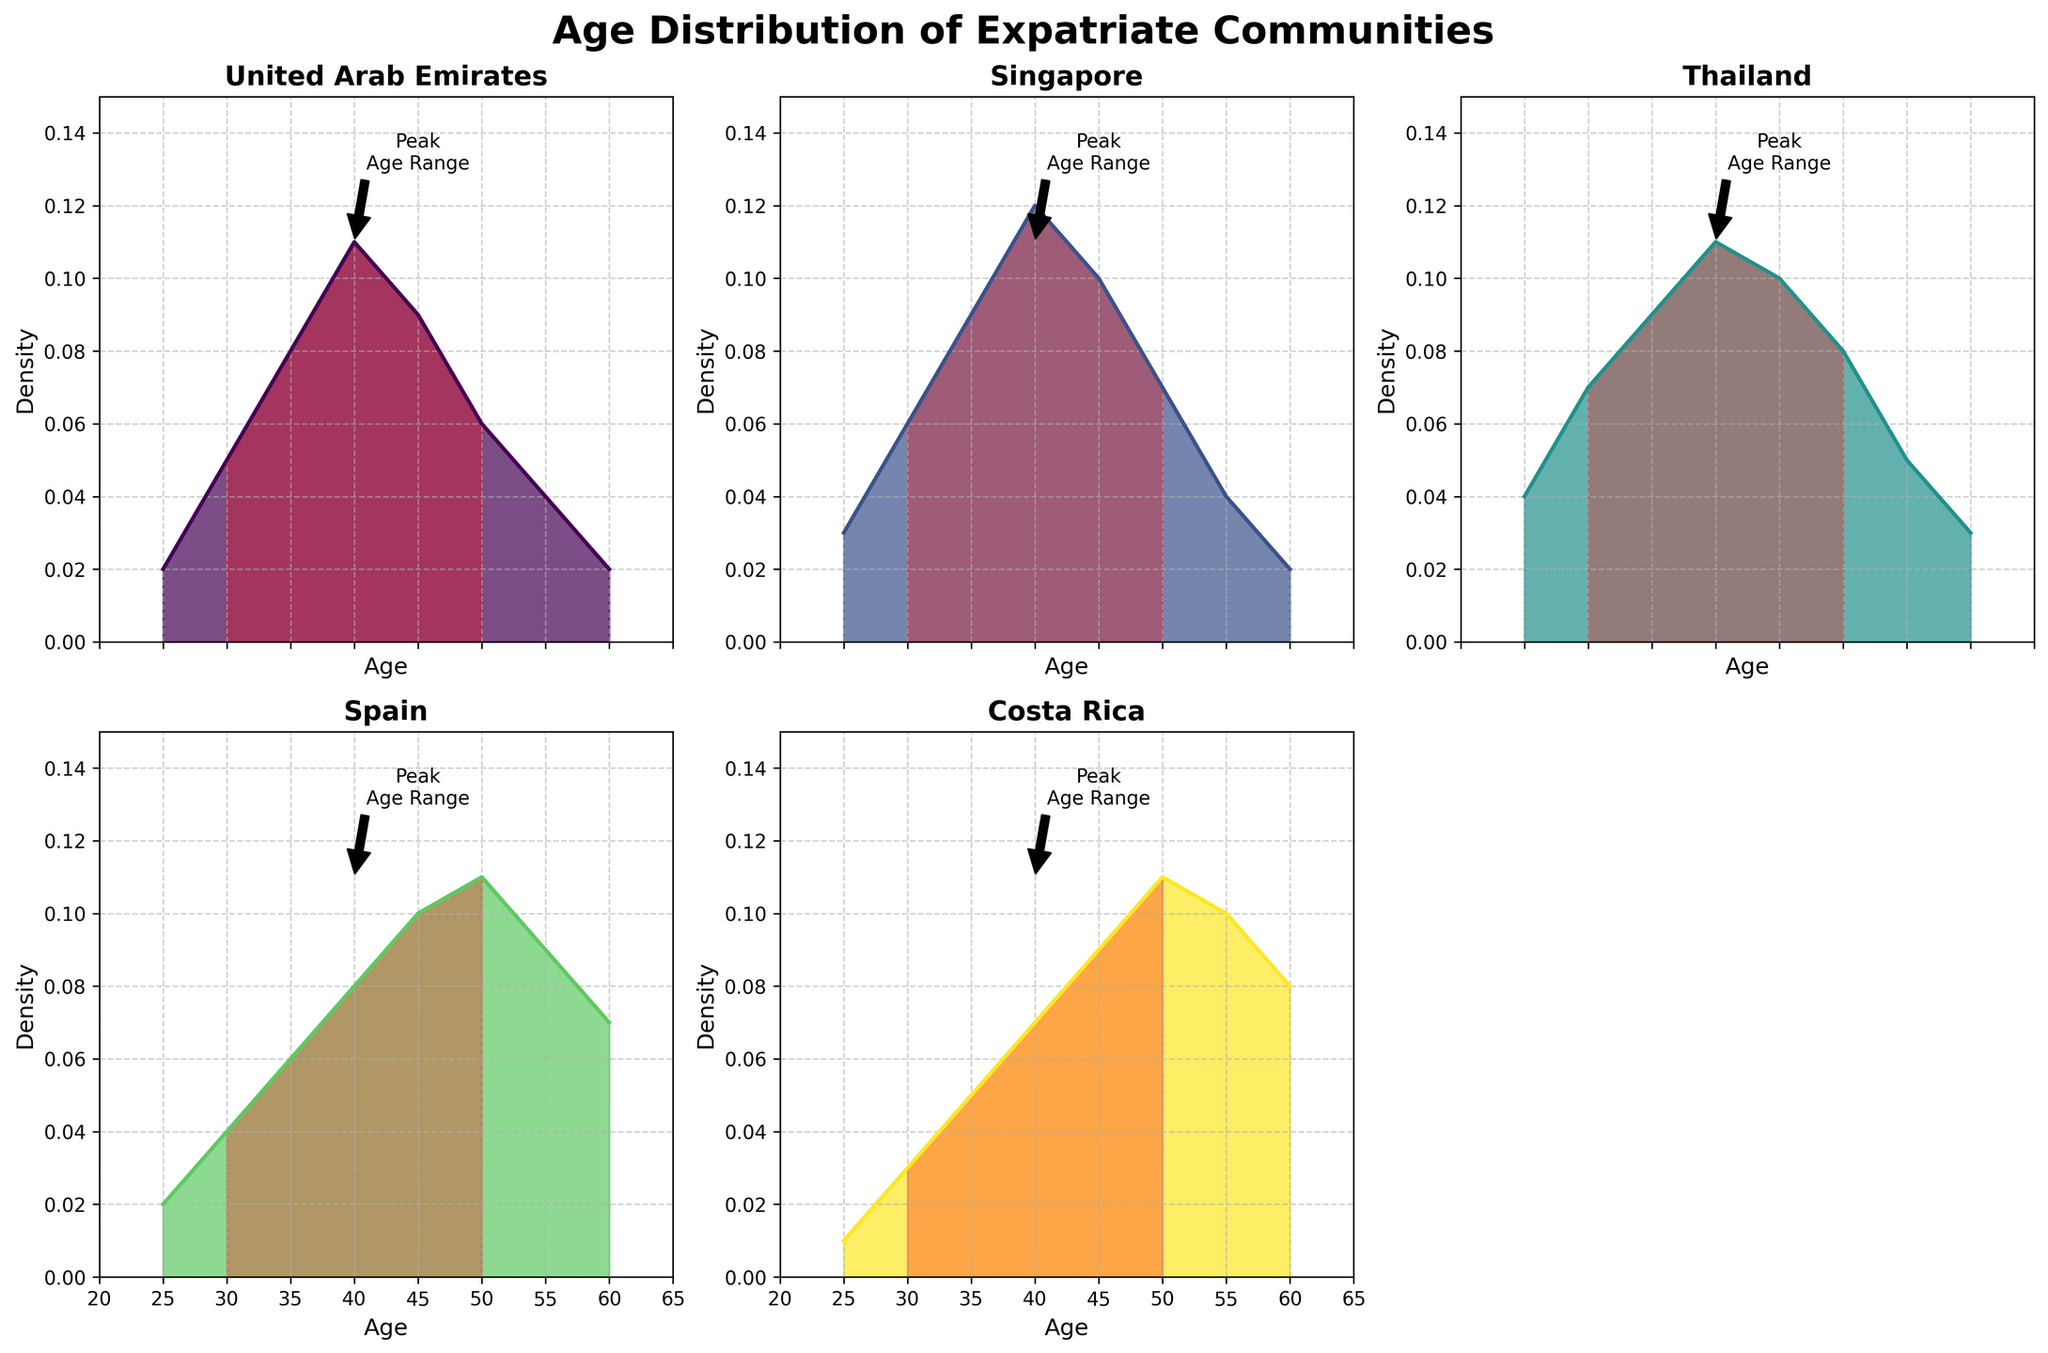What is the title of the figure? The title of the figure is clearly displayed at the top.
Answer: Age Distribution of Expatriate Communities Which country has the highest density of expatriates aged 40? From the subplot for each country, the highest density at age 40 can be observed.
Answer: Singapore What is the age range highlighted in red for each country? The subplots show a red shaded region between specific ages, which is the same for every country.
Answer: 30-50 Which country has the highest density of expatriates aged 55? By looking at the density values for each country at age 55, one can identify the highest value.
Answer: Costa Rica How does the density of expatriates aged 30 compare between the United Arab Emirates and Spain? By comparing the density values at age 30 in the respective subplots, we can determine the relationship.
Answer: Higher in UAE Which country has the flattest density distribution across ages 25 to 60? Observing the shapes of the density plots, the flattest distribution would have the least variation over the age range.
Answer: Costa Rica What is the approximate density value at age 50 for expatriates in Thailand? Checking the subplot for Thailand at the age 50 marker, we find the corresponding density value.
Answer: 0.08 In which subplot do we see the densest peak within the age range highlighted in red? The subplot with the densest peak in the highlighted red region can be identified by comparing the values.
Answer: Singapore Between which ages do expatriates in Spain see a steady increase in density? In Spain's subplot, we look for age ranges where the density values increase consistently.
Answer: 25 to 50 